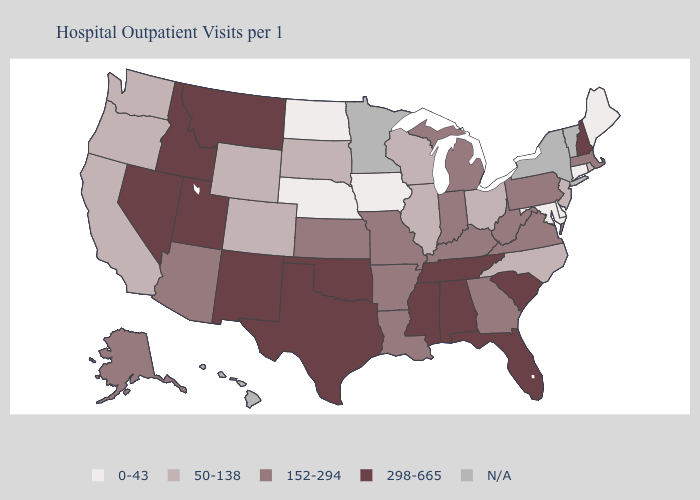What is the value of Arkansas?
Give a very brief answer. 152-294. Which states hav the highest value in the West?
Quick response, please. Idaho, Montana, Nevada, New Mexico, Utah. What is the lowest value in the MidWest?
Write a very short answer. 0-43. Is the legend a continuous bar?
Keep it brief. No. Among the states that border Connecticut , does Rhode Island have the lowest value?
Write a very short answer. Yes. Which states have the lowest value in the South?
Write a very short answer. Delaware, Maryland. What is the lowest value in states that border Nevada?
Give a very brief answer. 50-138. Name the states that have a value in the range 50-138?
Concise answer only. California, Colorado, Illinois, New Jersey, North Carolina, Ohio, Oregon, Rhode Island, South Dakota, Washington, Wisconsin, Wyoming. Name the states that have a value in the range N/A?
Short answer required. Hawaii, Minnesota, New York, Vermont. Which states have the highest value in the USA?
Keep it brief. Alabama, Florida, Idaho, Mississippi, Montana, Nevada, New Hampshire, New Mexico, Oklahoma, South Carolina, Tennessee, Texas, Utah. What is the value of Virginia?
Give a very brief answer. 152-294. What is the lowest value in states that border Illinois?
Concise answer only. 0-43. Is the legend a continuous bar?
Answer briefly. No. What is the value of North Carolina?
Give a very brief answer. 50-138. 